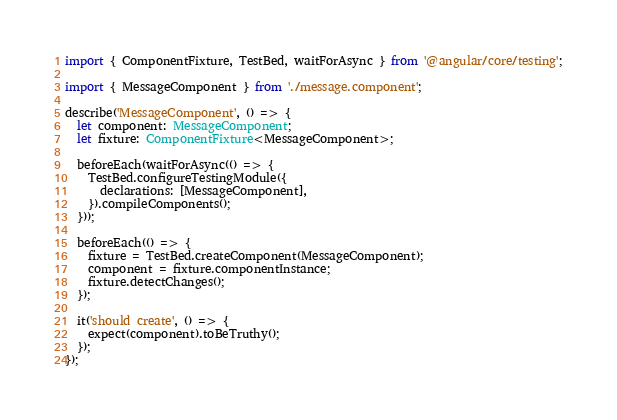Convert code to text. <code><loc_0><loc_0><loc_500><loc_500><_TypeScript_>import { ComponentFixture, TestBed, waitForAsync } from '@angular/core/testing';

import { MessageComponent } from './message.component';

describe('MessageComponent', () => {
  let component: MessageComponent;
  let fixture: ComponentFixture<MessageComponent>;

  beforeEach(waitForAsync(() => {
    TestBed.configureTestingModule({
      declarations: [MessageComponent],
    }).compileComponents();
  }));

  beforeEach(() => {
    fixture = TestBed.createComponent(MessageComponent);
    component = fixture.componentInstance;
    fixture.detectChanges();
  });

  it('should create', () => {
    expect(component).toBeTruthy();
  });
});
</code> 